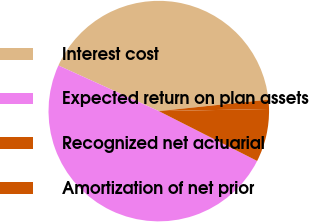Convert chart. <chart><loc_0><loc_0><loc_500><loc_500><pie_chart><fcel>Interest cost<fcel>Expected return on plan assets<fcel>Recognized net actuarial<fcel>Amortization of net prior<nl><fcel>41.55%<fcel>49.32%<fcel>7.77%<fcel>1.35%<nl></chart> 